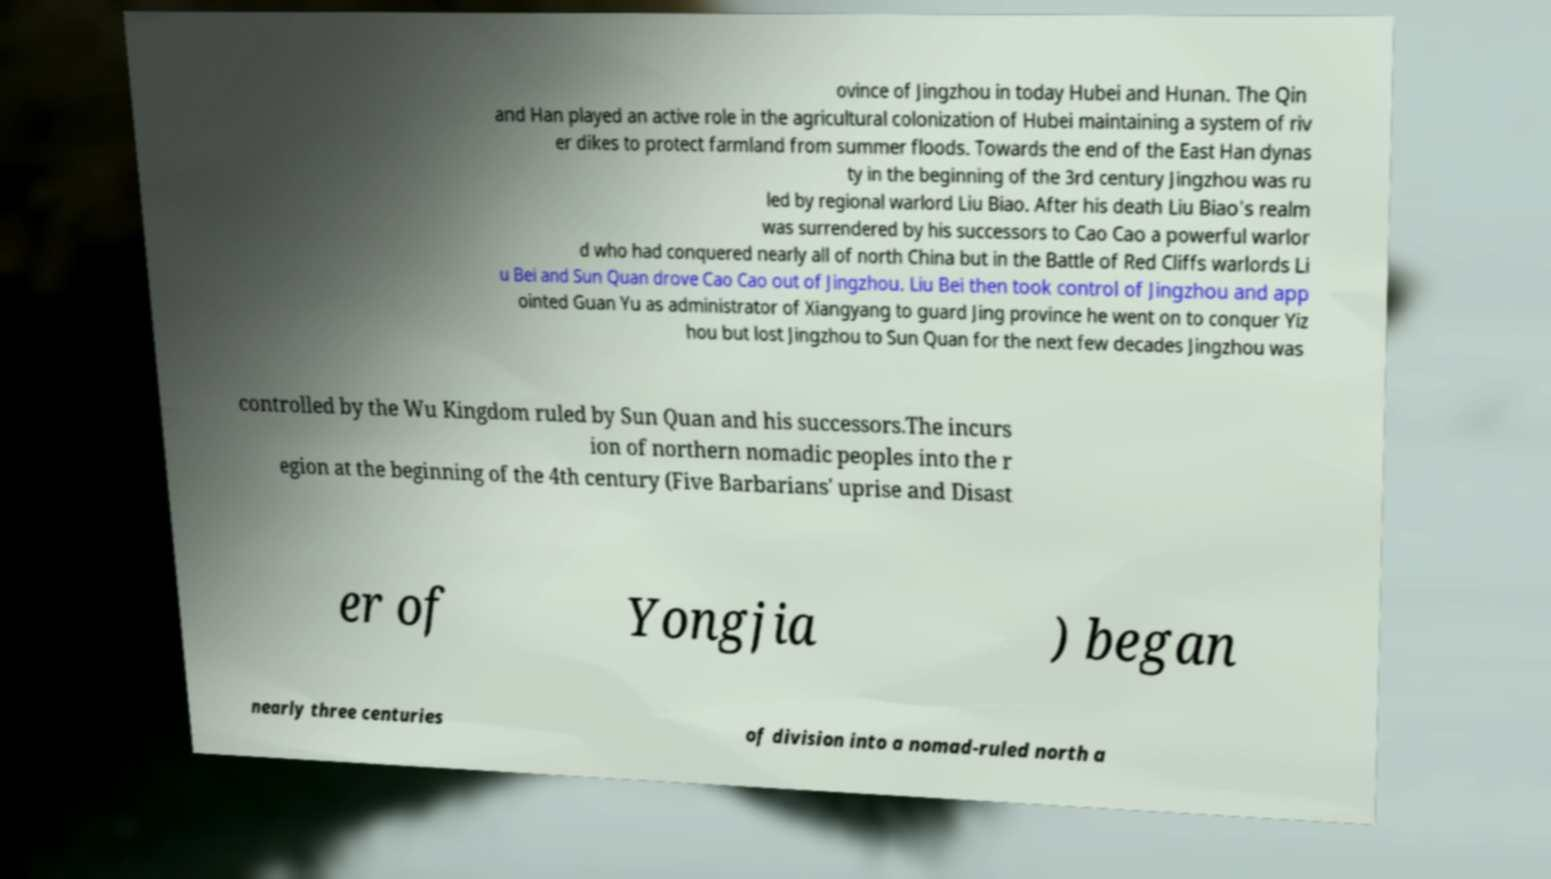Can you accurately transcribe the text from the provided image for me? ovince of Jingzhou in today Hubei and Hunan. The Qin and Han played an active role in the agricultural colonization of Hubei maintaining a system of riv er dikes to protect farmland from summer floods. Towards the end of the East Han dynas ty in the beginning of the 3rd century Jingzhou was ru led by regional warlord Liu Biao. After his death Liu Biao's realm was surrendered by his successors to Cao Cao a powerful warlor d who had conquered nearly all of north China but in the Battle of Red Cliffs warlords Li u Bei and Sun Quan drove Cao Cao out of Jingzhou. Liu Bei then took control of Jingzhou and app ointed Guan Yu as administrator of Xiangyang to guard Jing province he went on to conquer Yiz hou but lost Jingzhou to Sun Quan for the next few decades Jingzhou was controlled by the Wu Kingdom ruled by Sun Quan and his successors.The incurs ion of northern nomadic peoples into the r egion at the beginning of the 4th century (Five Barbarians' uprise and Disast er of Yongjia ) began nearly three centuries of division into a nomad-ruled north a 